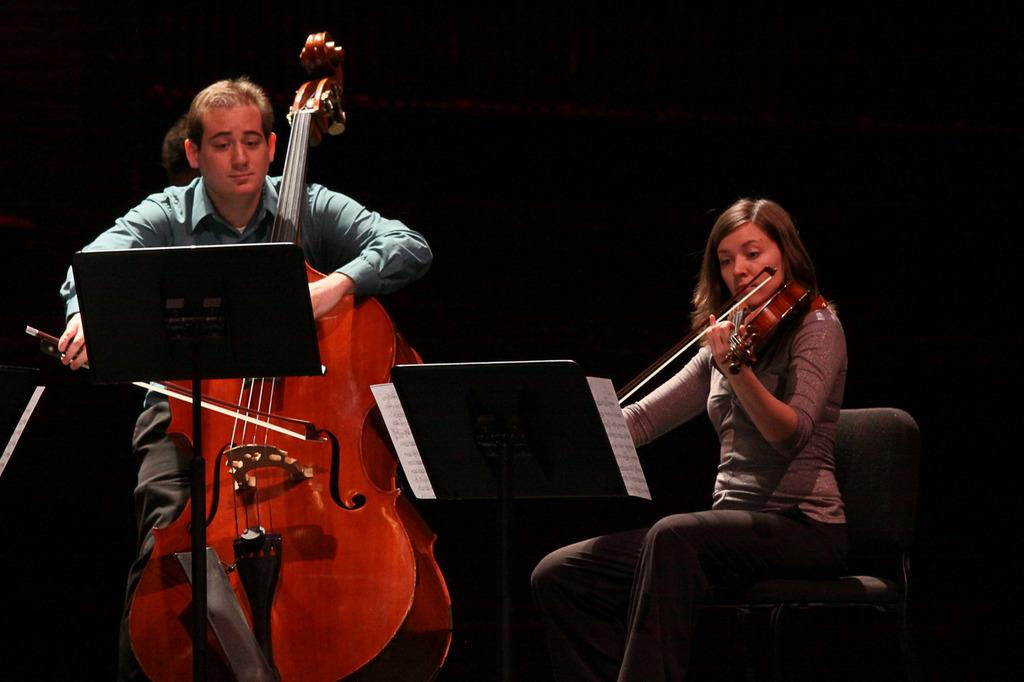How many people are in the image? There are two people in the image, a man and a woman. What are the man and woman doing in the image? The man and woman are both holding and playing violins. Can you describe the instruments they are playing? They are playing violins, which are stringed instruments. What type of treatment is the horse receiving in the image? There is no horse present in the image, so it is not possible to answer that question. 